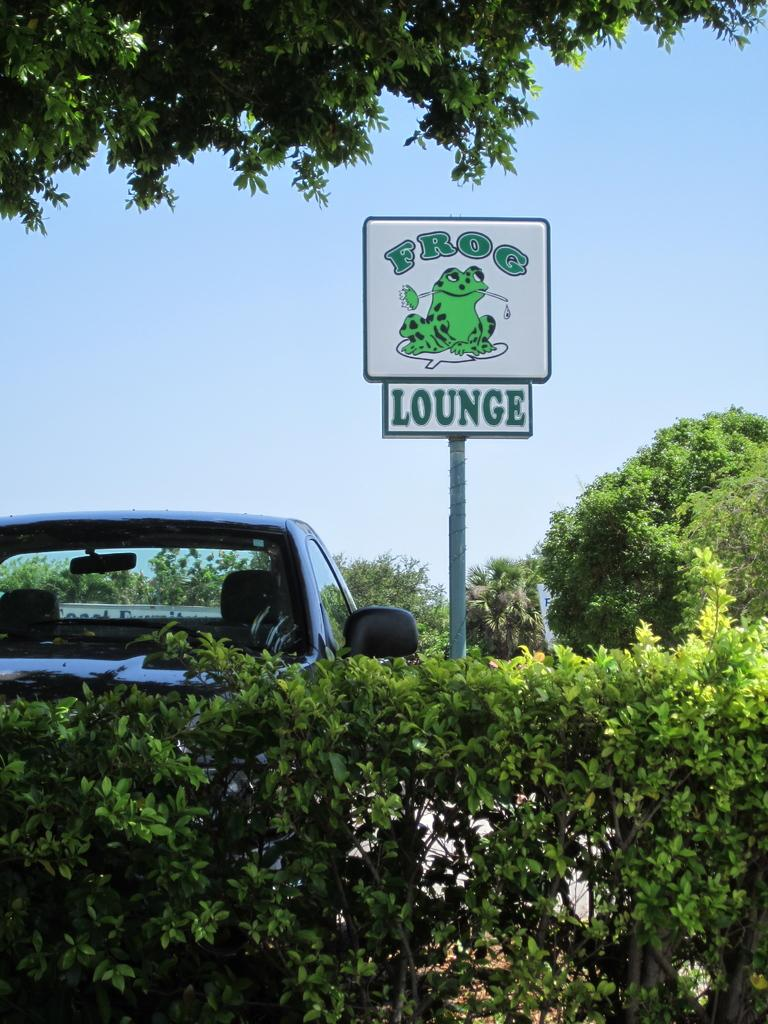What type of living organisms can be seen in the image? Plants and a cat are visible in the image. What type of vegetation is present in the image? There are trees in the image. What is the color of the sky in the image? The sky is visible in the image and has a blue color. What object can be seen in the image that is not a living organism or vegetation? There is a board in the image. Where is the tree located in the image? There is a tree at the top of the image. What type of account is being discussed in the image? There is no mention of an account in the image; it features plants, a cat, trees, a board, and the sky. 